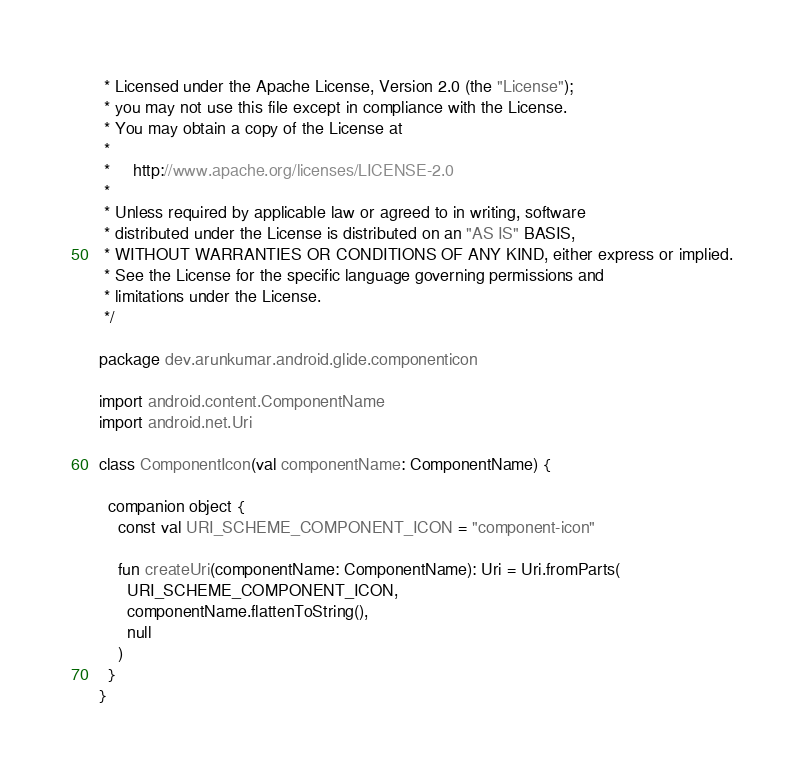Convert code to text. <code><loc_0><loc_0><loc_500><loc_500><_Kotlin_> * Licensed under the Apache License, Version 2.0 (the "License");
 * you may not use this file except in compliance with the License.
 * You may obtain a copy of the License at
 *
 *     http://www.apache.org/licenses/LICENSE-2.0
 *
 * Unless required by applicable law or agreed to in writing, software
 * distributed under the License is distributed on an "AS IS" BASIS,
 * WITHOUT WARRANTIES OR CONDITIONS OF ANY KIND, either express or implied.
 * See the License for the specific language governing permissions and
 * limitations under the License.
 */

package dev.arunkumar.android.glide.componenticon

import android.content.ComponentName
import android.net.Uri

class ComponentIcon(val componentName: ComponentName) {

  companion object {
    const val URI_SCHEME_COMPONENT_ICON = "component-icon"

    fun createUri(componentName: ComponentName): Uri = Uri.fromParts(
      URI_SCHEME_COMPONENT_ICON,
      componentName.flattenToString(),
      null
    )
  }
}</code> 